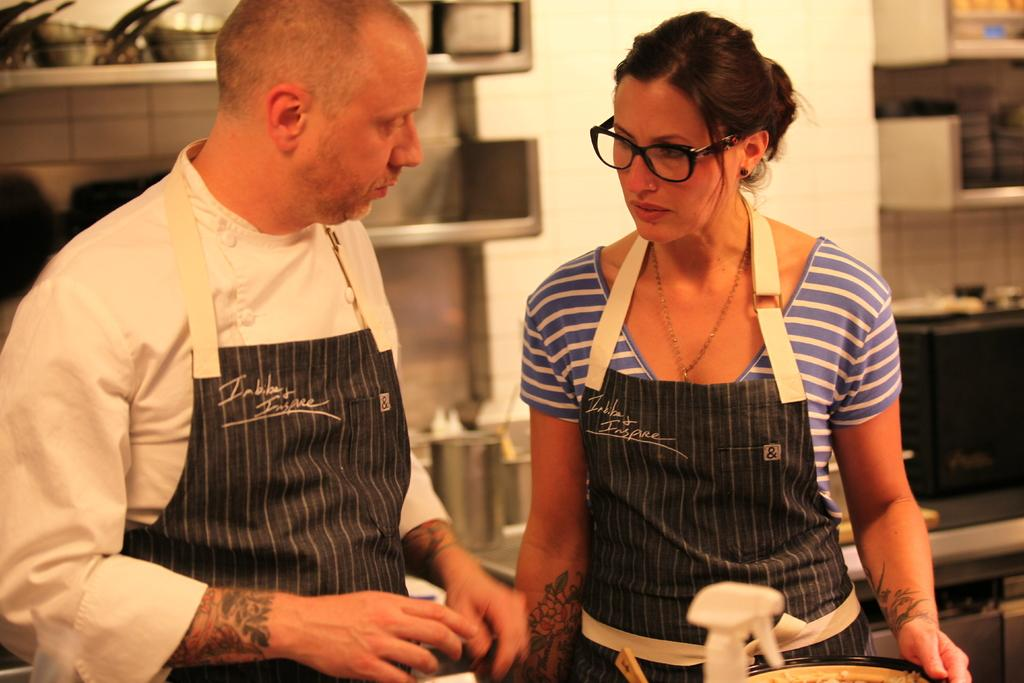How many people are in the image? There are two people in the image, a man and a woman. What are the man and woman wearing? The man and woman are both wearing aprons. Can you describe the woman's appearance? The woman is wearing glasses (specs). What can be seen in the background of the image? There are racks in the background of the image. What is on the racks? There are vessels on the racks. What type of cactus is growing in the background of the image? There is no cactus present in the image; the background features racks with vessels. 